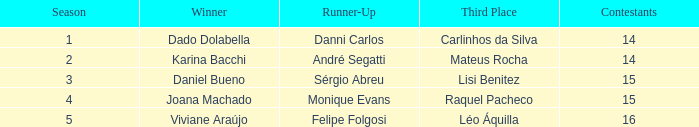In the contest where monique evans came in second place, what was the total number of contestants? 15.0. 